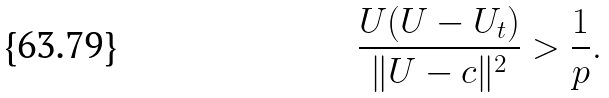<formula> <loc_0><loc_0><loc_500><loc_500>\frac { U ( U - U _ { t } ) } { \| U - c \| ^ { 2 } } > \frac { 1 } { p } .</formula> 